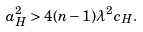Convert formula to latex. <formula><loc_0><loc_0><loc_500><loc_500>a _ { H } ^ { 2 } > 4 ( n - 1 ) \lambda ^ { 2 } c _ { H } .</formula> 